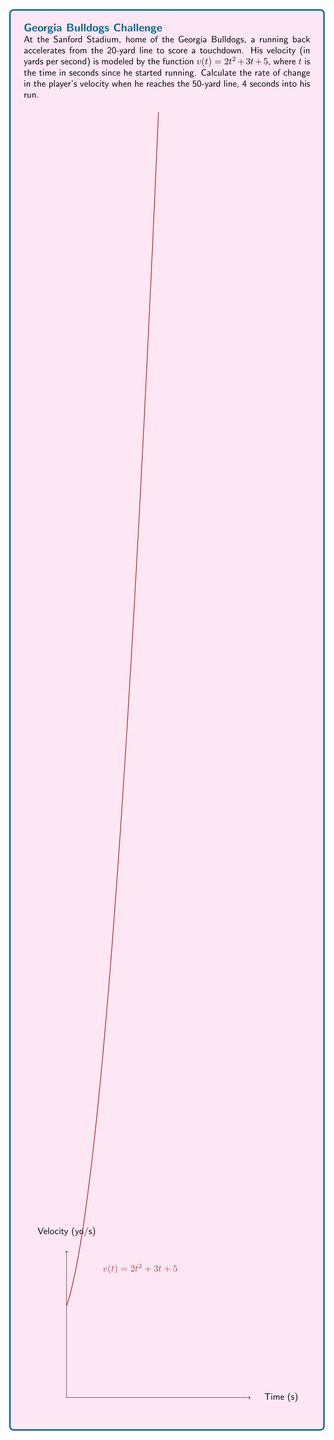Give your solution to this math problem. Let's approach this step-by-step:

1) The rate of change in velocity is the acceleration, which is given by the derivative of the velocity function.

2) We need to find $\frac{dv}{dt}$:
   $$\frac{dv}{dt} = \frac{d}{dt}(2t^2 + 3t + 5)$$

3) Using the power rule and the constant rule:
   $$\frac{dv}{dt} = 4t + 3$$

4) We're asked to find the rate of change at $t = 4$ seconds:
   $$\frac{dv}{dt}\bigg|_{t=4} = 4(4) + 3 = 16 + 3 = 19$$

5) Therefore, the rate of change in velocity (acceleration) at $t = 4$ seconds is 19 yards per second squared.
Answer: $19\, \text{yd}/\text{s}^2$ 